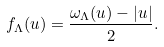<formula> <loc_0><loc_0><loc_500><loc_500>f _ { \Lambda } ( u ) = \frac { \omega _ { \Lambda } ( u ) - | u | } { 2 } .</formula> 